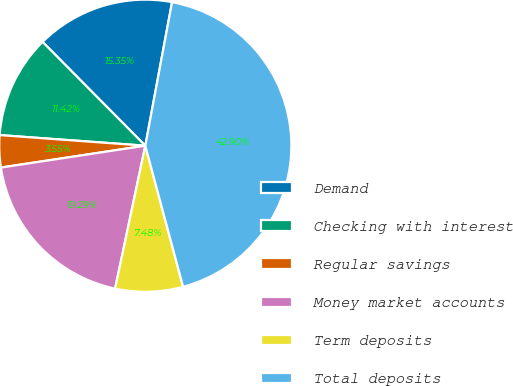Convert chart to OTSL. <chart><loc_0><loc_0><loc_500><loc_500><pie_chart><fcel>Demand<fcel>Checking with interest<fcel>Regular savings<fcel>Money market accounts<fcel>Term deposits<fcel>Total deposits<nl><fcel>15.35%<fcel>11.42%<fcel>3.55%<fcel>19.29%<fcel>7.48%<fcel>42.9%<nl></chart> 